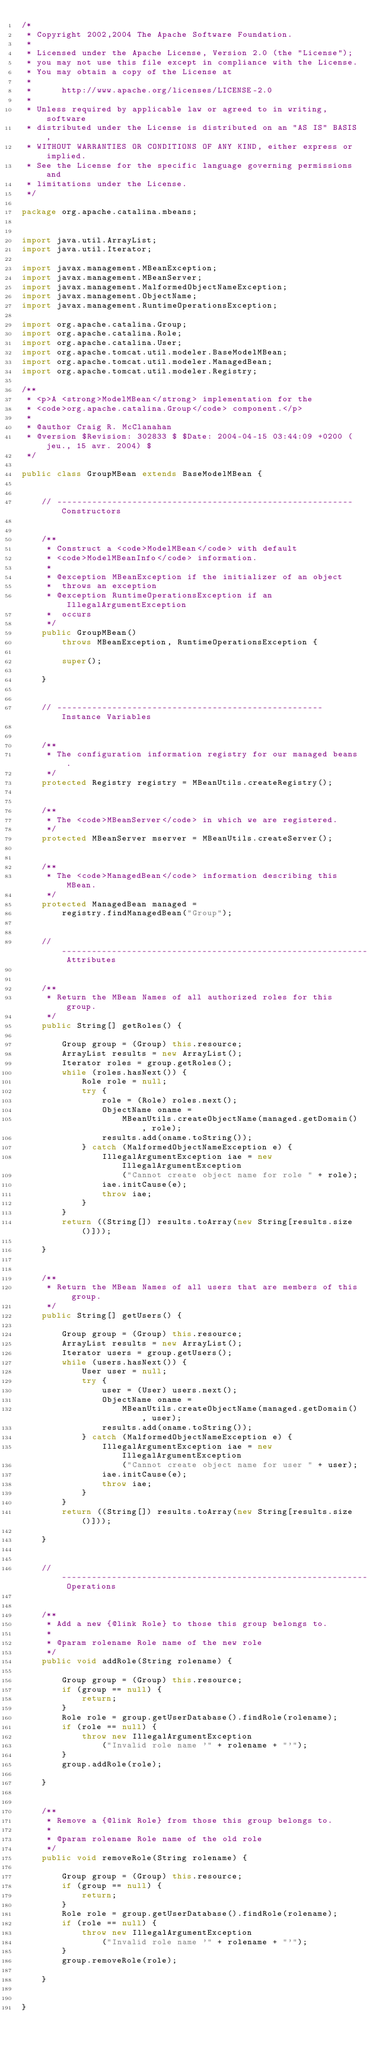Convert code to text. <code><loc_0><loc_0><loc_500><loc_500><_Java_>/*
 * Copyright 2002,2004 The Apache Software Foundation.
 * 
 * Licensed under the Apache License, Version 2.0 (the "License");
 * you may not use this file except in compliance with the License.
 * You may obtain a copy of the License at
 * 
 *      http://www.apache.org/licenses/LICENSE-2.0
 * 
 * Unless required by applicable law or agreed to in writing, software
 * distributed under the License is distributed on an "AS IS" BASIS,
 * WITHOUT WARRANTIES OR CONDITIONS OF ANY KIND, either express or implied.
 * See the License for the specific language governing permissions and
 * limitations under the License.
 */

package org.apache.catalina.mbeans;


import java.util.ArrayList;
import java.util.Iterator;

import javax.management.MBeanException;
import javax.management.MBeanServer;
import javax.management.MalformedObjectNameException;
import javax.management.ObjectName;
import javax.management.RuntimeOperationsException;

import org.apache.catalina.Group;
import org.apache.catalina.Role;
import org.apache.catalina.User;
import org.apache.tomcat.util.modeler.BaseModelMBean;
import org.apache.tomcat.util.modeler.ManagedBean;
import org.apache.tomcat.util.modeler.Registry;

/**
 * <p>A <strong>ModelMBean</strong> implementation for the
 * <code>org.apache.catalina.Group</code> component.</p>
 *
 * @author Craig R. McClanahan
 * @version $Revision: 302833 $ $Date: 2004-04-15 03:44:09 +0200 (jeu., 15 avr. 2004) $
 */

public class GroupMBean extends BaseModelMBean {


    // ----------------------------------------------------------- Constructors


    /**
     * Construct a <code>ModelMBean</code> with default
     * <code>ModelMBeanInfo</code> information.
     *
     * @exception MBeanException if the initializer of an object
     *  throws an exception
     * @exception RuntimeOperationsException if an IllegalArgumentException
     *  occurs
     */
    public GroupMBean()
        throws MBeanException, RuntimeOperationsException {

        super();

    }


    // ----------------------------------------------------- Instance Variables


    /**
     * The configuration information registry for our managed beans.
     */
    protected Registry registry = MBeanUtils.createRegistry();


    /**
     * The <code>MBeanServer</code> in which we are registered.
     */
    protected MBeanServer mserver = MBeanUtils.createServer();


    /**
     * The <code>ManagedBean</code> information describing this MBean.
     */
    protected ManagedBean managed =
        registry.findManagedBean("Group");


    // ------------------------------------------------------------- Attributes


    /**
     * Return the MBean Names of all authorized roles for this group.
     */
    public String[] getRoles() {

        Group group = (Group) this.resource;
        ArrayList results = new ArrayList();
        Iterator roles = group.getRoles();
        while (roles.hasNext()) {
            Role role = null;
            try {
                role = (Role) roles.next();
                ObjectName oname =
                    MBeanUtils.createObjectName(managed.getDomain(), role);
                results.add(oname.toString());
            } catch (MalformedObjectNameException e) {
                IllegalArgumentException iae = new IllegalArgumentException
                    ("Cannot create object name for role " + role);
                iae.initCause(e);
                throw iae;
            }
        }
        return ((String[]) results.toArray(new String[results.size()]));

    }


    /**
     * Return the MBean Names of all users that are members of this group.
     */
    public String[] getUsers() {

        Group group = (Group) this.resource;
        ArrayList results = new ArrayList();
        Iterator users = group.getUsers();
        while (users.hasNext()) {
            User user = null;
            try {
                user = (User) users.next();
                ObjectName oname =
                    MBeanUtils.createObjectName(managed.getDomain(), user);
                results.add(oname.toString());
            } catch (MalformedObjectNameException e) {
                IllegalArgumentException iae = new IllegalArgumentException
                    ("Cannot create object name for user " + user);
                iae.initCause(e);
                throw iae;
            }
        }
        return ((String[]) results.toArray(new String[results.size()]));

    }


    // ------------------------------------------------------------- Operations


    /**
     * Add a new {@link Role} to those this group belongs to.
     *
     * @param rolename Role name of the new role
     */
    public void addRole(String rolename) {

        Group group = (Group) this.resource;
        if (group == null) {
            return;
        }
        Role role = group.getUserDatabase().findRole(rolename);
        if (role == null) {
            throw new IllegalArgumentException
                ("Invalid role name '" + rolename + "'");
        }
        group.addRole(role);

    }


    /**
     * Remove a {@link Role} from those this group belongs to.
     *
     * @param rolename Role name of the old role
     */
    public void removeRole(String rolename) {

        Group group = (Group) this.resource;
        if (group == null) {
            return;
        }
        Role role = group.getUserDatabase().findRole(rolename);
        if (role == null) {
            throw new IllegalArgumentException
                ("Invalid role name '" + rolename + "'");
        }
        group.removeRole(role);

    }


}
</code> 